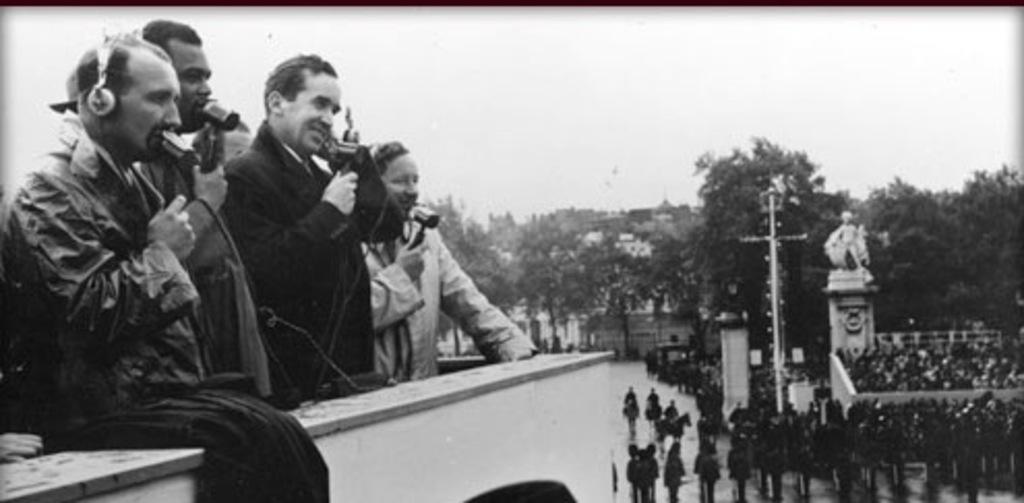In one or two sentences, can you explain what this image depicts? There are some people standing on the left side. They are holding mics. One person is wearing a headphones. On the right side there are many people. There is a pole, building and trees. In the background there is sky. And it is a black and white picture. 